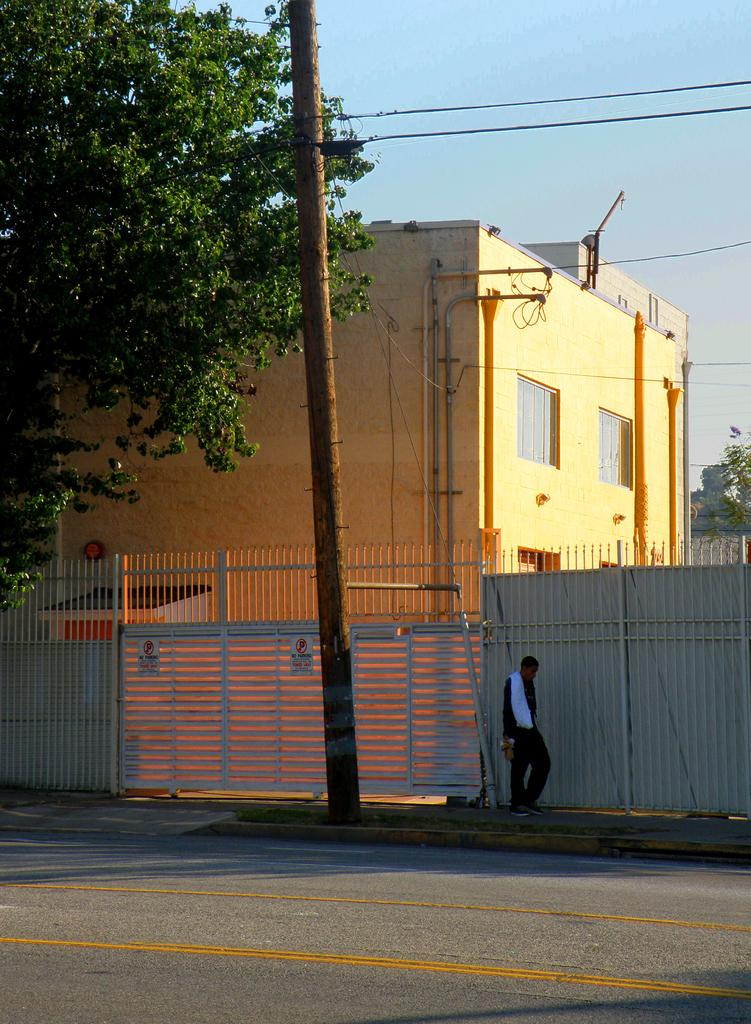What is the man in the image doing? The man is walking in the image. On what surface is the man walking? The man is walking on a sidewalk. What can be seen in the background of the image? The sky is visible in the background of the image. What type of structure is present in the image? There is a house in the image. What is attached to the pole in the image? Wires are visible in the image, attached to the pole. What color is the man's touch in the image? The man's touch does not have a color, as it is not a visible element in the image. 